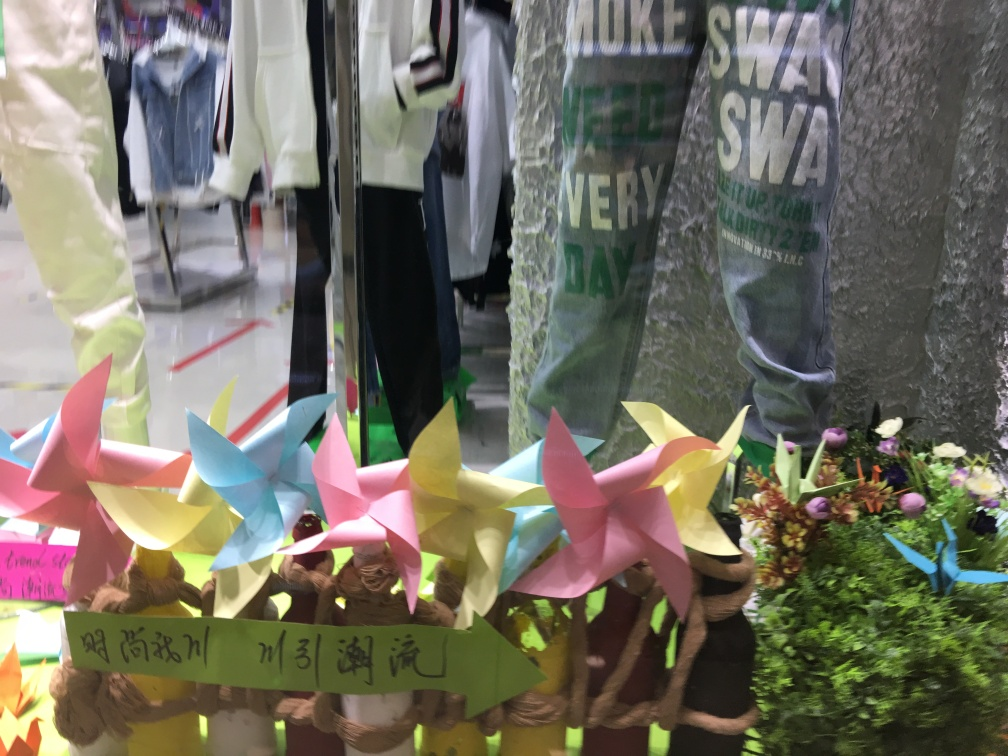What elements are predominant in this image? The image prominently features colorful paper pinwheels in the foreground, which are traditionally associated with peace and childlike whimsy. There's also a display of assorted flowers adding a natural touch, and through the glass, one can see clothing items on sale. The reflection and the actual contents blend, creating an interesting yet busy visual. 